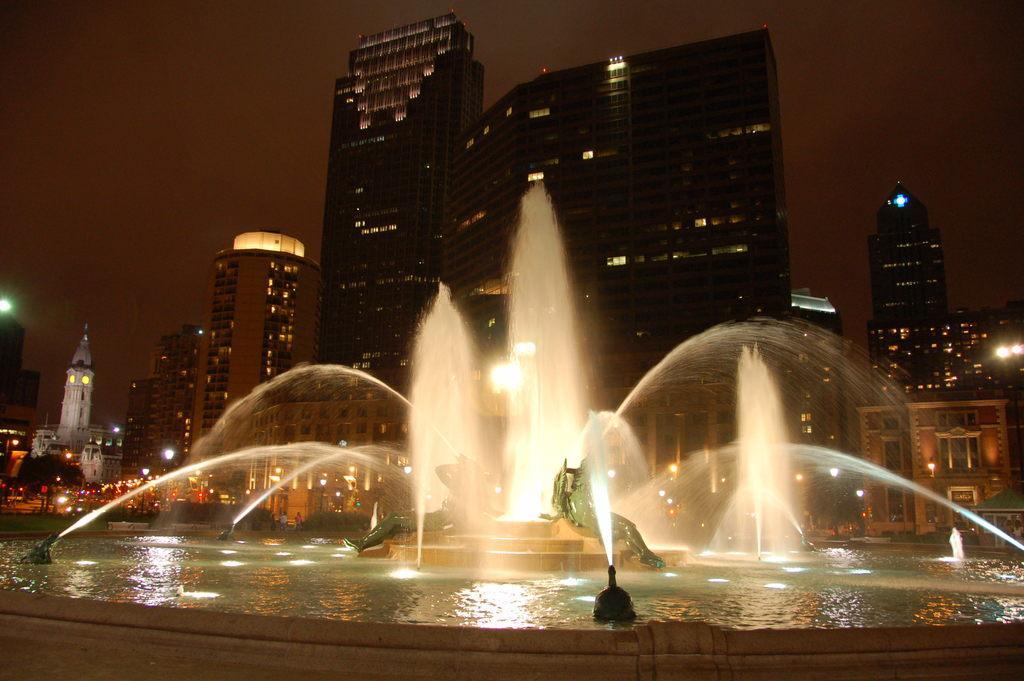Describe this image in one or two sentences. In this image we can see there are buildings, in front of them there is a fountain, at the center of the fountain there are statues. In the background there is a sky. 